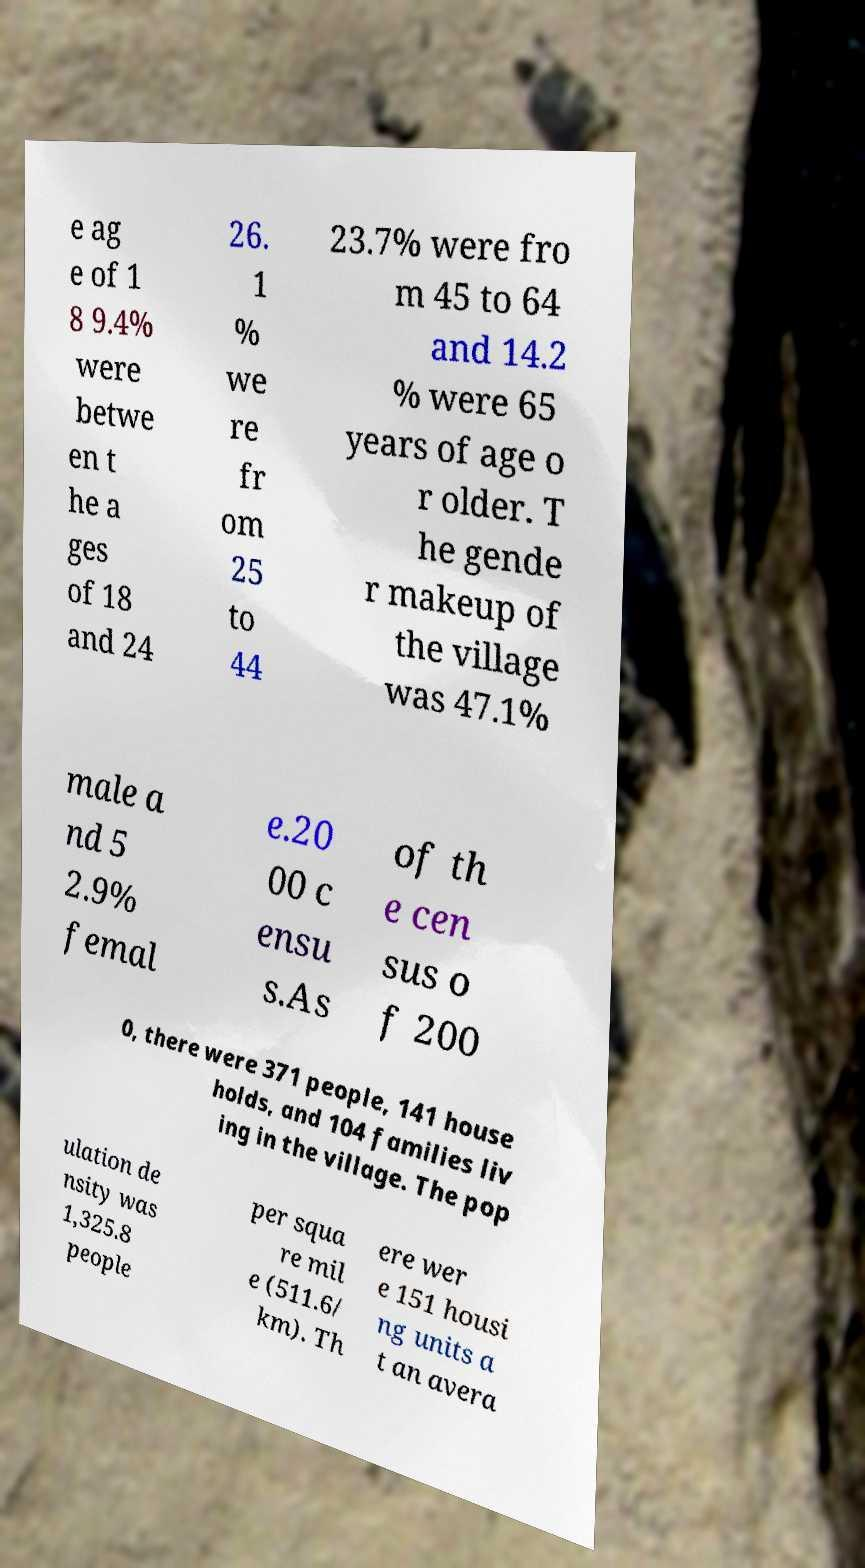There's text embedded in this image that I need extracted. Can you transcribe it verbatim? e ag e of 1 8 9.4% were betwe en t he a ges of 18 and 24 26. 1 % we re fr om 25 to 44 23.7% were fro m 45 to 64 and 14.2 % were 65 years of age o r older. T he gende r makeup of the village was 47.1% male a nd 5 2.9% femal e.20 00 c ensu s.As of th e cen sus o f 200 0, there were 371 people, 141 house holds, and 104 families liv ing in the village. The pop ulation de nsity was 1,325.8 people per squa re mil e (511.6/ km). Th ere wer e 151 housi ng units a t an avera 